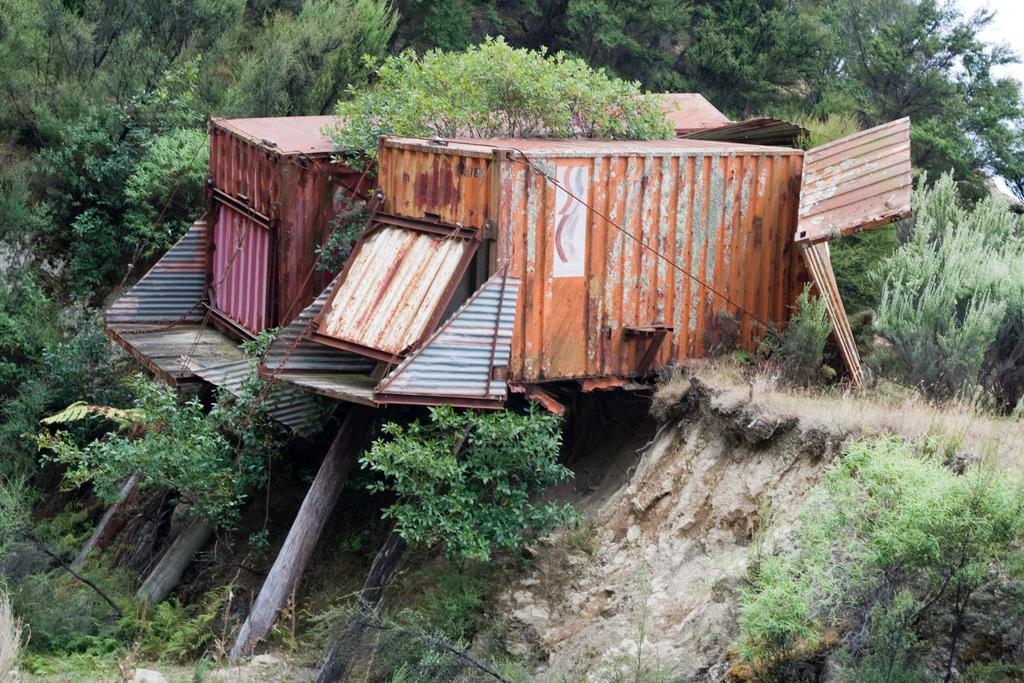In one or two sentences, can you explain what this image depicts? In this picture we can see sheds, plants, wooden poles and trees. In the background of the image we can see the sky. 